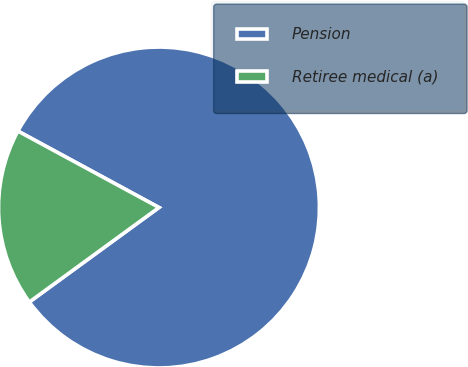Convert chart to OTSL. <chart><loc_0><loc_0><loc_500><loc_500><pie_chart><fcel>Pension<fcel>Retiree medical (a)<nl><fcel>82.07%<fcel>17.93%<nl></chart> 